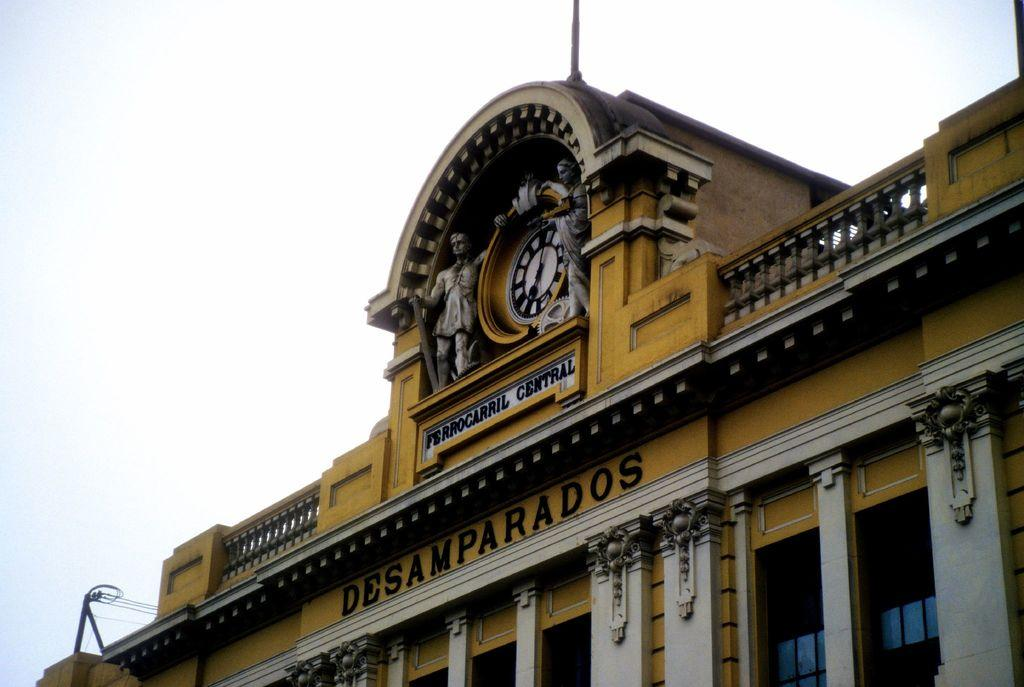<image>
Create a compact narrative representing the image presented. The top of a clock tower that reads Desamparados 